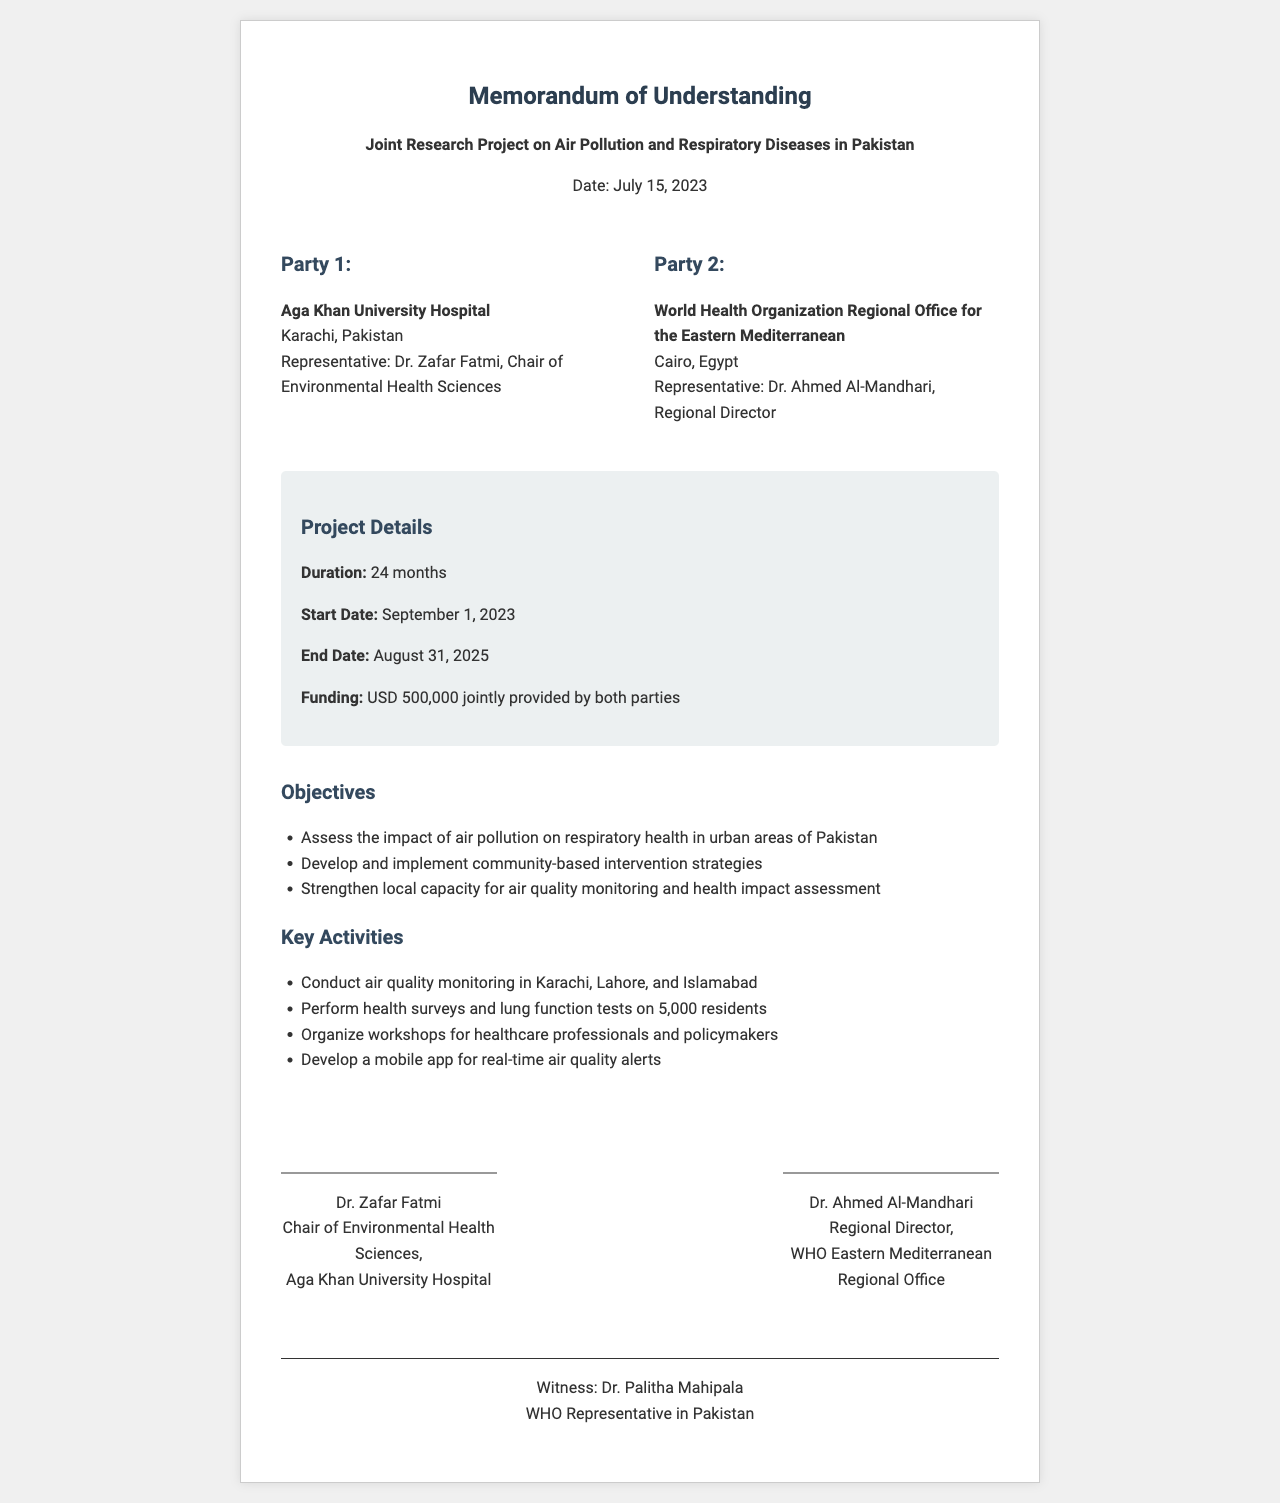What is the document title? The document title is specified at the top of the fax and identifies the purpose of the communication.
Answer: Memorandum of Understanding Who is the representative of Party 1? The representative is listed under Party 1, which provides the name and title of the individual.
Answer: Dr. Zafar Fatmi What is the start date of the project? The start date is mentioned in the project details section of the document as the beginning of the research project timeline.
Answer: September 1, 2023 What is the total funding amount for the project? The funding amount is explicitly stated in the project details, indicating the financial resources for the joint research.
Answer: USD 500,000 What are one of the key activities mentioned? The key activities are listed as part of the project’s execution, and this requires identifying one from the document.
Answer: Conduct air quality monitoring in Karachi, Lahore, and Islamabad Who signed on behalf of the World Health Organization? The person who signed for the WHO represents Party 2, and their name is given in the signatures section.
Answer: Dr. Ahmed Al-Mandhari How long is the project duration? The duration is described in the project details, providing a clear timeline for the length of the joint research.
Answer: 24 months What city is Aga Khan University Hospital located in? The location of Party 1 is specified in the document, indicating where the organization is based.
Answer: Karachi What is the role of Dr. Palitha Mahipala according to the document? The document mentions the role of the witness in the context of the agreement’s legitimacy, and this role is described in the final section.
Answer: WHO Representative in Pakistan 